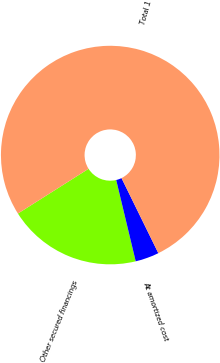Convert chart. <chart><loc_0><loc_0><loc_500><loc_500><pie_chart><fcel>Other secured financings<fcel>At amortized cost<fcel>Total 1<nl><fcel>19.76%<fcel>3.51%<fcel>76.73%<nl></chart> 